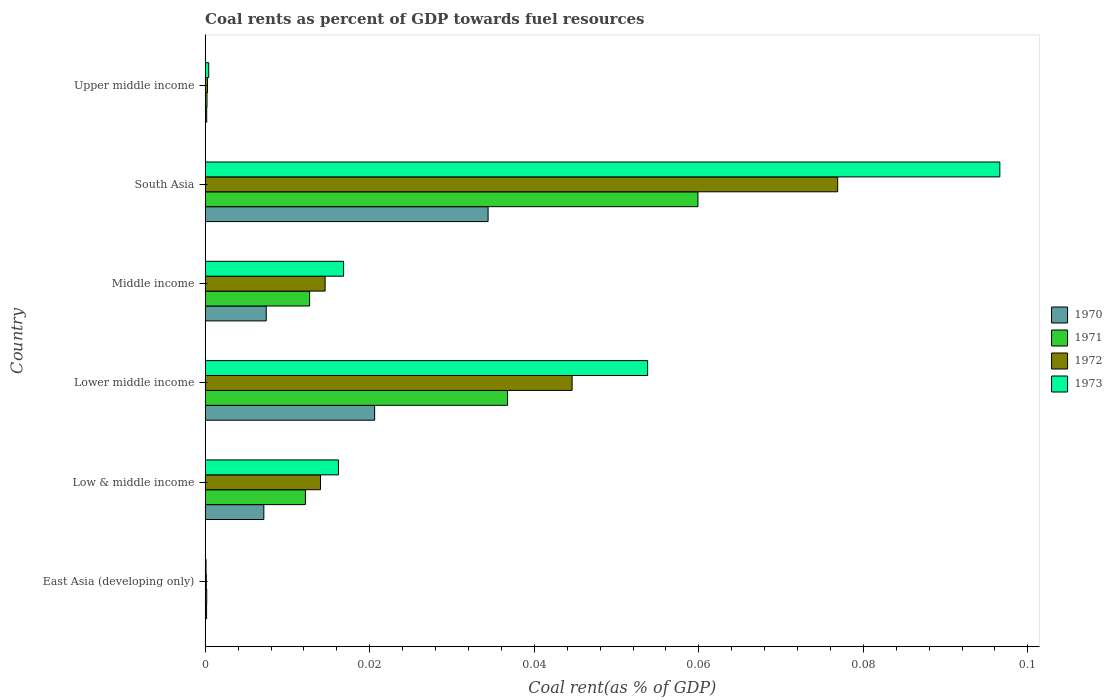How many different coloured bars are there?
Offer a very short reply. 4. How many groups of bars are there?
Your answer should be very brief. 6. Are the number of bars per tick equal to the number of legend labels?
Provide a short and direct response. Yes. Are the number of bars on each tick of the Y-axis equal?
Provide a short and direct response. Yes. How many bars are there on the 5th tick from the top?
Your response must be concise. 4. How many bars are there on the 3rd tick from the bottom?
Offer a terse response. 4. In how many cases, is the number of bars for a given country not equal to the number of legend labels?
Keep it short and to the point. 0. What is the coal rent in 1970 in East Asia (developing only)?
Provide a short and direct response. 0. Across all countries, what is the maximum coal rent in 1971?
Your response must be concise. 0.06. Across all countries, what is the minimum coal rent in 1973?
Your answer should be compact. 0. In which country was the coal rent in 1972 maximum?
Offer a very short reply. South Asia. In which country was the coal rent in 1971 minimum?
Your answer should be very brief. East Asia (developing only). What is the total coal rent in 1973 in the graph?
Your answer should be compact. 0.18. What is the difference between the coal rent in 1970 in Low & middle income and that in South Asia?
Your response must be concise. -0.03. What is the difference between the coal rent in 1973 in East Asia (developing only) and the coal rent in 1972 in Upper middle income?
Offer a terse response. -0. What is the average coal rent in 1971 per country?
Ensure brevity in your answer.  0.02. What is the difference between the coal rent in 1970 and coal rent in 1972 in South Asia?
Make the answer very short. -0.04. In how many countries, is the coal rent in 1970 greater than 0.068 %?
Your answer should be compact. 0. What is the ratio of the coal rent in 1971 in East Asia (developing only) to that in Middle income?
Ensure brevity in your answer.  0.01. Is the coal rent in 1970 in Lower middle income less than that in Middle income?
Provide a succinct answer. No. Is the difference between the coal rent in 1970 in Lower middle income and Middle income greater than the difference between the coal rent in 1972 in Lower middle income and Middle income?
Your answer should be very brief. No. What is the difference between the highest and the second highest coal rent in 1970?
Give a very brief answer. 0.01. What is the difference between the highest and the lowest coal rent in 1972?
Provide a succinct answer. 0.08. What does the 2nd bar from the bottom in East Asia (developing only) represents?
Offer a very short reply. 1971. Is it the case that in every country, the sum of the coal rent in 1972 and coal rent in 1970 is greater than the coal rent in 1973?
Keep it short and to the point. Yes. How many countries are there in the graph?
Provide a short and direct response. 6. What is the difference between two consecutive major ticks on the X-axis?
Your answer should be very brief. 0.02. Does the graph contain any zero values?
Make the answer very short. No. Does the graph contain grids?
Provide a short and direct response. No. How many legend labels are there?
Offer a terse response. 4. What is the title of the graph?
Your response must be concise. Coal rents as percent of GDP towards fuel resources. Does "1992" appear as one of the legend labels in the graph?
Offer a very short reply. No. What is the label or title of the X-axis?
Provide a succinct answer. Coal rent(as % of GDP). What is the Coal rent(as % of GDP) of 1970 in East Asia (developing only)?
Your answer should be very brief. 0. What is the Coal rent(as % of GDP) of 1971 in East Asia (developing only)?
Provide a succinct answer. 0. What is the Coal rent(as % of GDP) of 1972 in East Asia (developing only)?
Offer a very short reply. 0. What is the Coal rent(as % of GDP) in 1973 in East Asia (developing only)?
Provide a succinct answer. 0. What is the Coal rent(as % of GDP) in 1970 in Low & middle income?
Your answer should be compact. 0.01. What is the Coal rent(as % of GDP) of 1971 in Low & middle income?
Your answer should be compact. 0.01. What is the Coal rent(as % of GDP) of 1972 in Low & middle income?
Give a very brief answer. 0.01. What is the Coal rent(as % of GDP) in 1973 in Low & middle income?
Provide a short and direct response. 0.02. What is the Coal rent(as % of GDP) in 1970 in Lower middle income?
Offer a very short reply. 0.02. What is the Coal rent(as % of GDP) in 1971 in Lower middle income?
Keep it short and to the point. 0.04. What is the Coal rent(as % of GDP) in 1972 in Lower middle income?
Your answer should be very brief. 0.04. What is the Coal rent(as % of GDP) in 1973 in Lower middle income?
Give a very brief answer. 0.05. What is the Coal rent(as % of GDP) in 1970 in Middle income?
Provide a short and direct response. 0.01. What is the Coal rent(as % of GDP) in 1971 in Middle income?
Offer a terse response. 0.01. What is the Coal rent(as % of GDP) of 1972 in Middle income?
Offer a very short reply. 0.01. What is the Coal rent(as % of GDP) in 1973 in Middle income?
Offer a terse response. 0.02. What is the Coal rent(as % of GDP) of 1970 in South Asia?
Your answer should be very brief. 0.03. What is the Coal rent(as % of GDP) in 1971 in South Asia?
Provide a short and direct response. 0.06. What is the Coal rent(as % of GDP) in 1972 in South Asia?
Make the answer very short. 0.08. What is the Coal rent(as % of GDP) of 1973 in South Asia?
Offer a very short reply. 0.1. What is the Coal rent(as % of GDP) in 1970 in Upper middle income?
Ensure brevity in your answer.  0. What is the Coal rent(as % of GDP) in 1971 in Upper middle income?
Your response must be concise. 0. What is the Coal rent(as % of GDP) of 1972 in Upper middle income?
Provide a succinct answer. 0. What is the Coal rent(as % of GDP) in 1973 in Upper middle income?
Give a very brief answer. 0. Across all countries, what is the maximum Coal rent(as % of GDP) in 1970?
Keep it short and to the point. 0.03. Across all countries, what is the maximum Coal rent(as % of GDP) of 1971?
Your response must be concise. 0.06. Across all countries, what is the maximum Coal rent(as % of GDP) of 1972?
Offer a very short reply. 0.08. Across all countries, what is the maximum Coal rent(as % of GDP) of 1973?
Your answer should be very brief. 0.1. Across all countries, what is the minimum Coal rent(as % of GDP) in 1970?
Keep it short and to the point. 0. Across all countries, what is the minimum Coal rent(as % of GDP) of 1971?
Provide a short and direct response. 0. Across all countries, what is the minimum Coal rent(as % of GDP) in 1972?
Offer a terse response. 0. Across all countries, what is the minimum Coal rent(as % of GDP) of 1973?
Your answer should be very brief. 0. What is the total Coal rent(as % of GDP) in 1970 in the graph?
Offer a very short reply. 0.07. What is the total Coal rent(as % of GDP) of 1971 in the graph?
Your response must be concise. 0.12. What is the total Coal rent(as % of GDP) in 1972 in the graph?
Ensure brevity in your answer.  0.15. What is the total Coal rent(as % of GDP) of 1973 in the graph?
Keep it short and to the point. 0.18. What is the difference between the Coal rent(as % of GDP) in 1970 in East Asia (developing only) and that in Low & middle income?
Provide a short and direct response. -0.01. What is the difference between the Coal rent(as % of GDP) of 1971 in East Asia (developing only) and that in Low & middle income?
Your answer should be compact. -0.01. What is the difference between the Coal rent(as % of GDP) in 1972 in East Asia (developing only) and that in Low & middle income?
Make the answer very short. -0.01. What is the difference between the Coal rent(as % of GDP) in 1973 in East Asia (developing only) and that in Low & middle income?
Offer a terse response. -0.02. What is the difference between the Coal rent(as % of GDP) of 1970 in East Asia (developing only) and that in Lower middle income?
Offer a very short reply. -0.02. What is the difference between the Coal rent(as % of GDP) of 1971 in East Asia (developing only) and that in Lower middle income?
Your answer should be compact. -0.04. What is the difference between the Coal rent(as % of GDP) in 1972 in East Asia (developing only) and that in Lower middle income?
Keep it short and to the point. -0.04. What is the difference between the Coal rent(as % of GDP) of 1973 in East Asia (developing only) and that in Lower middle income?
Your response must be concise. -0.05. What is the difference between the Coal rent(as % of GDP) of 1970 in East Asia (developing only) and that in Middle income?
Your answer should be very brief. -0.01. What is the difference between the Coal rent(as % of GDP) of 1971 in East Asia (developing only) and that in Middle income?
Your response must be concise. -0.01. What is the difference between the Coal rent(as % of GDP) of 1972 in East Asia (developing only) and that in Middle income?
Offer a very short reply. -0.01. What is the difference between the Coal rent(as % of GDP) in 1973 in East Asia (developing only) and that in Middle income?
Make the answer very short. -0.02. What is the difference between the Coal rent(as % of GDP) in 1970 in East Asia (developing only) and that in South Asia?
Keep it short and to the point. -0.03. What is the difference between the Coal rent(as % of GDP) in 1971 in East Asia (developing only) and that in South Asia?
Give a very brief answer. -0.06. What is the difference between the Coal rent(as % of GDP) of 1972 in East Asia (developing only) and that in South Asia?
Make the answer very short. -0.08. What is the difference between the Coal rent(as % of GDP) in 1973 in East Asia (developing only) and that in South Asia?
Your answer should be compact. -0.1. What is the difference between the Coal rent(as % of GDP) of 1970 in East Asia (developing only) and that in Upper middle income?
Offer a very short reply. -0. What is the difference between the Coal rent(as % of GDP) in 1972 in East Asia (developing only) and that in Upper middle income?
Offer a terse response. -0. What is the difference between the Coal rent(as % of GDP) of 1973 in East Asia (developing only) and that in Upper middle income?
Ensure brevity in your answer.  -0. What is the difference between the Coal rent(as % of GDP) of 1970 in Low & middle income and that in Lower middle income?
Your answer should be compact. -0.01. What is the difference between the Coal rent(as % of GDP) in 1971 in Low & middle income and that in Lower middle income?
Offer a very short reply. -0.02. What is the difference between the Coal rent(as % of GDP) of 1972 in Low & middle income and that in Lower middle income?
Your response must be concise. -0.03. What is the difference between the Coal rent(as % of GDP) of 1973 in Low & middle income and that in Lower middle income?
Keep it short and to the point. -0.04. What is the difference between the Coal rent(as % of GDP) in 1970 in Low & middle income and that in Middle income?
Make the answer very short. -0. What is the difference between the Coal rent(as % of GDP) in 1971 in Low & middle income and that in Middle income?
Your response must be concise. -0. What is the difference between the Coal rent(as % of GDP) of 1972 in Low & middle income and that in Middle income?
Ensure brevity in your answer.  -0. What is the difference between the Coal rent(as % of GDP) of 1973 in Low & middle income and that in Middle income?
Provide a succinct answer. -0. What is the difference between the Coal rent(as % of GDP) in 1970 in Low & middle income and that in South Asia?
Your answer should be very brief. -0.03. What is the difference between the Coal rent(as % of GDP) in 1971 in Low & middle income and that in South Asia?
Your response must be concise. -0.05. What is the difference between the Coal rent(as % of GDP) of 1972 in Low & middle income and that in South Asia?
Make the answer very short. -0.06. What is the difference between the Coal rent(as % of GDP) of 1973 in Low & middle income and that in South Asia?
Ensure brevity in your answer.  -0.08. What is the difference between the Coal rent(as % of GDP) in 1970 in Low & middle income and that in Upper middle income?
Make the answer very short. 0.01. What is the difference between the Coal rent(as % of GDP) of 1971 in Low & middle income and that in Upper middle income?
Ensure brevity in your answer.  0.01. What is the difference between the Coal rent(as % of GDP) of 1972 in Low & middle income and that in Upper middle income?
Ensure brevity in your answer.  0.01. What is the difference between the Coal rent(as % of GDP) in 1973 in Low & middle income and that in Upper middle income?
Offer a terse response. 0.02. What is the difference between the Coal rent(as % of GDP) of 1970 in Lower middle income and that in Middle income?
Make the answer very short. 0.01. What is the difference between the Coal rent(as % of GDP) in 1971 in Lower middle income and that in Middle income?
Your response must be concise. 0.02. What is the difference between the Coal rent(as % of GDP) in 1972 in Lower middle income and that in Middle income?
Your answer should be very brief. 0.03. What is the difference between the Coal rent(as % of GDP) of 1973 in Lower middle income and that in Middle income?
Offer a terse response. 0.04. What is the difference between the Coal rent(as % of GDP) of 1970 in Lower middle income and that in South Asia?
Provide a short and direct response. -0.01. What is the difference between the Coal rent(as % of GDP) of 1971 in Lower middle income and that in South Asia?
Your answer should be very brief. -0.02. What is the difference between the Coal rent(as % of GDP) in 1972 in Lower middle income and that in South Asia?
Your answer should be very brief. -0.03. What is the difference between the Coal rent(as % of GDP) of 1973 in Lower middle income and that in South Asia?
Give a very brief answer. -0.04. What is the difference between the Coal rent(as % of GDP) in 1970 in Lower middle income and that in Upper middle income?
Your answer should be compact. 0.02. What is the difference between the Coal rent(as % of GDP) in 1971 in Lower middle income and that in Upper middle income?
Your response must be concise. 0.04. What is the difference between the Coal rent(as % of GDP) of 1972 in Lower middle income and that in Upper middle income?
Ensure brevity in your answer.  0.04. What is the difference between the Coal rent(as % of GDP) of 1973 in Lower middle income and that in Upper middle income?
Keep it short and to the point. 0.05. What is the difference between the Coal rent(as % of GDP) of 1970 in Middle income and that in South Asia?
Your response must be concise. -0.03. What is the difference between the Coal rent(as % of GDP) in 1971 in Middle income and that in South Asia?
Your response must be concise. -0.05. What is the difference between the Coal rent(as % of GDP) of 1972 in Middle income and that in South Asia?
Give a very brief answer. -0.06. What is the difference between the Coal rent(as % of GDP) in 1973 in Middle income and that in South Asia?
Make the answer very short. -0.08. What is the difference between the Coal rent(as % of GDP) in 1970 in Middle income and that in Upper middle income?
Offer a terse response. 0.01. What is the difference between the Coal rent(as % of GDP) of 1971 in Middle income and that in Upper middle income?
Offer a terse response. 0.01. What is the difference between the Coal rent(as % of GDP) of 1972 in Middle income and that in Upper middle income?
Your answer should be compact. 0.01. What is the difference between the Coal rent(as % of GDP) in 1973 in Middle income and that in Upper middle income?
Provide a succinct answer. 0.02. What is the difference between the Coal rent(as % of GDP) in 1970 in South Asia and that in Upper middle income?
Ensure brevity in your answer.  0.03. What is the difference between the Coal rent(as % of GDP) of 1971 in South Asia and that in Upper middle income?
Offer a terse response. 0.06. What is the difference between the Coal rent(as % of GDP) in 1972 in South Asia and that in Upper middle income?
Provide a short and direct response. 0.08. What is the difference between the Coal rent(as % of GDP) of 1973 in South Asia and that in Upper middle income?
Give a very brief answer. 0.1. What is the difference between the Coal rent(as % of GDP) of 1970 in East Asia (developing only) and the Coal rent(as % of GDP) of 1971 in Low & middle income?
Provide a succinct answer. -0.01. What is the difference between the Coal rent(as % of GDP) in 1970 in East Asia (developing only) and the Coal rent(as % of GDP) in 1972 in Low & middle income?
Make the answer very short. -0.01. What is the difference between the Coal rent(as % of GDP) in 1970 in East Asia (developing only) and the Coal rent(as % of GDP) in 1973 in Low & middle income?
Give a very brief answer. -0.02. What is the difference between the Coal rent(as % of GDP) of 1971 in East Asia (developing only) and the Coal rent(as % of GDP) of 1972 in Low & middle income?
Your answer should be compact. -0.01. What is the difference between the Coal rent(as % of GDP) in 1971 in East Asia (developing only) and the Coal rent(as % of GDP) in 1973 in Low & middle income?
Your answer should be very brief. -0.02. What is the difference between the Coal rent(as % of GDP) of 1972 in East Asia (developing only) and the Coal rent(as % of GDP) of 1973 in Low & middle income?
Offer a very short reply. -0.02. What is the difference between the Coal rent(as % of GDP) in 1970 in East Asia (developing only) and the Coal rent(as % of GDP) in 1971 in Lower middle income?
Your response must be concise. -0.04. What is the difference between the Coal rent(as % of GDP) of 1970 in East Asia (developing only) and the Coal rent(as % of GDP) of 1972 in Lower middle income?
Give a very brief answer. -0.04. What is the difference between the Coal rent(as % of GDP) of 1970 in East Asia (developing only) and the Coal rent(as % of GDP) of 1973 in Lower middle income?
Offer a terse response. -0.05. What is the difference between the Coal rent(as % of GDP) in 1971 in East Asia (developing only) and the Coal rent(as % of GDP) in 1972 in Lower middle income?
Offer a terse response. -0.04. What is the difference between the Coal rent(as % of GDP) in 1971 in East Asia (developing only) and the Coal rent(as % of GDP) in 1973 in Lower middle income?
Your answer should be very brief. -0.05. What is the difference between the Coal rent(as % of GDP) in 1972 in East Asia (developing only) and the Coal rent(as % of GDP) in 1973 in Lower middle income?
Provide a short and direct response. -0.05. What is the difference between the Coal rent(as % of GDP) of 1970 in East Asia (developing only) and the Coal rent(as % of GDP) of 1971 in Middle income?
Offer a very short reply. -0.01. What is the difference between the Coal rent(as % of GDP) of 1970 in East Asia (developing only) and the Coal rent(as % of GDP) of 1972 in Middle income?
Your response must be concise. -0.01. What is the difference between the Coal rent(as % of GDP) of 1970 in East Asia (developing only) and the Coal rent(as % of GDP) of 1973 in Middle income?
Offer a terse response. -0.02. What is the difference between the Coal rent(as % of GDP) in 1971 in East Asia (developing only) and the Coal rent(as % of GDP) in 1972 in Middle income?
Your answer should be compact. -0.01. What is the difference between the Coal rent(as % of GDP) in 1971 in East Asia (developing only) and the Coal rent(as % of GDP) in 1973 in Middle income?
Your answer should be compact. -0.02. What is the difference between the Coal rent(as % of GDP) in 1972 in East Asia (developing only) and the Coal rent(as % of GDP) in 1973 in Middle income?
Your answer should be very brief. -0.02. What is the difference between the Coal rent(as % of GDP) in 1970 in East Asia (developing only) and the Coal rent(as % of GDP) in 1971 in South Asia?
Offer a terse response. -0.06. What is the difference between the Coal rent(as % of GDP) in 1970 in East Asia (developing only) and the Coal rent(as % of GDP) in 1972 in South Asia?
Ensure brevity in your answer.  -0.08. What is the difference between the Coal rent(as % of GDP) in 1970 in East Asia (developing only) and the Coal rent(as % of GDP) in 1973 in South Asia?
Make the answer very short. -0.1. What is the difference between the Coal rent(as % of GDP) of 1971 in East Asia (developing only) and the Coal rent(as % of GDP) of 1972 in South Asia?
Offer a terse response. -0.08. What is the difference between the Coal rent(as % of GDP) in 1971 in East Asia (developing only) and the Coal rent(as % of GDP) in 1973 in South Asia?
Keep it short and to the point. -0.1. What is the difference between the Coal rent(as % of GDP) in 1972 in East Asia (developing only) and the Coal rent(as % of GDP) in 1973 in South Asia?
Give a very brief answer. -0.1. What is the difference between the Coal rent(as % of GDP) of 1970 in East Asia (developing only) and the Coal rent(as % of GDP) of 1971 in Upper middle income?
Provide a short and direct response. -0. What is the difference between the Coal rent(as % of GDP) in 1970 in East Asia (developing only) and the Coal rent(as % of GDP) in 1972 in Upper middle income?
Give a very brief answer. -0. What is the difference between the Coal rent(as % of GDP) in 1970 in East Asia (developing only) and the Coal rent(as % of GDP) in 1973 in Upper middle income?
Offer a very short reply. -0. What is the difference between the Coal rent(as % of GDP) in 1971 in East Asia (developing only) and the Coal rent(as % of GDP) in 1972 in Upper middle income?
Your answer should be very brief. -0. What is the difference between the Coal rent(as % of GDP) in 1971 in East Asia (developing only) and the Coal rent(as % of GDP) in 1973 in Upper middle income?
Keep it short and to the point. -0. What is the difference between the Coal rent(as % of GDP) in 1972 in East Asia (developing only) and the Coal rent(as % of GDP) in 1973 in Upper middle income?
Your answer should be very brief. -0. What is the difference between the Coal rent(as % of GDP) of 1970 in Low & middle income and the Coal rent(as % of GDP) of 1971 in Lower middle income?
Provide a succinct answer. -0.03. What is the difference between the Coal rent(as % of GDP) in 1970 in Low & middle income and the Coal rent(as % of GDP) in 1972 in Lower middle income?
Give a very brief answer. -0.04. What is the difference between the Coal rent(as % of GDP) of 1970 in Low & middle income and the Coal rent(as % of GDP) of 1973 in Lower middle income?
Offer a terse response. -0.05. What is the difference between the Coal rent(as % of GDP) of 1971 in Low & middle income and the Coal rent(as % of GDP) of 1972 in Lower middle income?
Give a very brief answer. -0.03. What is the difference between the Coal rent(as % of GDP) in 1971 in Low & middle income and the Coal rent(as % of GDP) in 1973 in Lower middle income?
Your answer should be compact. -0.04. What is the difference between the Coal rent(as % of GDP) of 1972 in Low & middle income and the Coal rent(as % of GDP) of 1973 in Lower middle income?
Give a very brief answer. -0.04. What is the difference between the Coal rent(as % of GDP) in 1970 in Low & middle income and the Coal rent(as % of GDP) in 1971 in Middle income?
Offer a terse response. -0.01. What is the difference between the Coal rent(as % of GDP) of 1970 in Low & middle income and the Coal rent(as % of GDP) of 1972 in Middle income?
Your answer should be very brief. -0.01. What is the difference between the Coal rent(as % of GDP) of 1970 in Low & middle income and the Coal rent(as % of GDP) of 1973 in Middle income?
Provide a succinct answer. -0.01. What is the difference between the Coal rent(as % of GDP) in 1971 in Low & middle income and the Coal rent(as % of GDP) in 1972 in Middle income?
Your response must be concise. -0. What is the difference between the Coal rent(as % of GDP) of 1971 in Low & middle income and the Coal rent(as % of GDP) of 1973 in Middle income?
Give a very brief answer. -0. What is the difference between the Coal rent(as % of GDP) in 1972 in Low & middle income and the Coal rent(as % of GDP) in 1973 in Middle income?
Give a very brief answer. -0. What is the difference between the Coal rent(as % of GDP) in 1970 in Low & middle income and the Coal rent(as % of GDP) in 1971 in South Asia?
Ensure brevity in your answer.  -0.05. What is the difference between the Coal rent(as % of GDP) of 1970 in Low & middle income and the Coal rent(as % of GDP) of 1972 in South Asia?
Offer a very short reply. -0.07. What is the difference between the Coal rent(as % of GDP) in 1970 in Low & middle income and the Coal rent(as % of GDP) in 1973 in South Asia?
Offer a very short reply. -0.09. What is the difference between the Coal rent(as % of GDP) in 1971 in Low & middle income and the Coal rent(as % of GDP) in 1972 in South Asia?
Your answer should be very brief. -0.06. What is the difference between the Coal rent(as % of GDP) in 1971 in Low & middle income and the Coal rent(as % of GDP) in 1973 in South Asia?
Your answer should be very brief. -0.08. What is the difference between the Coal rent(as % of GDP) of 1972 in Low & middle income and the Coal rent(as % of GDP) of 1973 in South Asia?
Your answer should be compact. -0.08. What is the difference between the Coal rent(as % of GDP) of 1970 in Low & middle income and the Coal rent(as % of GDP) of 1971 in Upper middle income?
Offer a terse response. 0.01. What is the difference between the Coal rent(as % of GDP) of 1970 in Low & middle income and the Coal rent(as % of GDP) of 1972 in Upper middle income?
Offer a very short reply. 0.01. What is the difference between the Coal rent(as % of GDP) in 1970 in Low & middle income and the Coal rent(as % of GDP) in 1973 in Upper middle income?
Give a very brief answer. 0.01. What is the difference between the Coal rent(as % of GDP) in 1971 in Low & middle income and the Coal rent(as % of GDP) in 1972 in Upper middle income?
Provide a short and direct response. 0.01. What is the difference between the Coal rent(as % of GDP) in 1971 in Low & middle income and the Coal rent(as % of GDP) in 1973 in Upper middle income?
Your response must be concise. 0.01. What is the difference between the Coal rent(as % of GDP) of 1972 in Low & middle income and the Coal rent(as % of GDP) of 1973 in Upper middle income?
Offer a very short reply. 0.01. What is the difference between the Coal rent(as % of GDP) of 1970 in Lower middle income and the Coal rent(as % of GDP) of 1971 in Middle income?
Ensure brevity in your answer.  0.01. What is the difference between the Coal rent(as % of GDP) of 1970 in Lower middle income and the Coal rent(as % of GDP) of 1972 in Middle income?
Make the answer very short. 0.01. What is the difference between the Coal rent(as % of GDP) of 1970 in Lower middle income and the Coal rent(as % of GDP) of 1973 in Middle income?
Keep it short and to the point. 0. What is the difference between the Coal rent(as % of GDP) of 1971 in Lower middle income and the Coal rent(as % of GDP) of 1972 in Middle income?
Your response must be concise. 0.02. What is the difference between the Coal rent(as % of GDP) in 1971 in Lower middle income and the Coal rent(as % of GDP) in 1973 in Middle income?
Your response must be concise. 0.02. What is the difference between the Coal rent(as % of GDP) in 1972 in Lower middle income and the Coal rent(as % of GDP) in 1973 in Middle income?
Your answer should be compact. 0.03. What is the difference between the Coal rent(as % of GDP) of 1970 in Lower middle income and the Coal rent(as % of GDP) of 1971 in South Asia?
Your response must be concise. -0.04. What is the difference between the Coal rent(as % of GDP) in 1970 in Lower middle income and the Coal rent(as % of GDP) in 1972 in South Asia?
Your answer should be very brief. -0.06. What is the difference between the Coal rent(as % of GDP) of 1970 in Lower middle income and the Coal rent(as % of GDP) of 1973 in South Asia?
Offer a very short reply. -0.08. What is the difference between the Coal rent(as % of GDP) of 1971 in Lower middle income and the Coal rent(as % of GDP) of 1972 in South Asia?
Your answer should be compact. -0.04. What is the difference between the Coal rent(as % of GDP) of 1971 in Lower middle income and the Coal rent(as % of GDP) of 1973 in South Asia?
Your answer should be compact. -0.06. What is the difference between the Coal rent(as % of GDP) in 1972 in Lower middle income and the Coal rent(as % of GDP) in 1973 in South Asia?
Make the answer very short. -0.05. What is the difference between the Coal rent(as % of GDP) in 1970 in Lower middle income and the Coal rent(as % of GDP) in 1971 in Upper middle income?
Your answer should be very brief. 0.02. What is the difference between the Coal rent(as % of GDP) of 1970 in Lower middle income and the Coal rent(as % of GDP) of 1972 in Upper middle income?
Offer a very short reply. 0.02. What is the difference between the Coal rent(as % of GDP) in 1970 in Lower middle income and the Coal rent(as % of GDP) in 1973 in Upper middle income?
Your response must be concise. 0.02. What is the difference between the Coal rent(as % of GDP) of 1971 in Lower middle income and the Coal rent(as % of GDP) of 1972 in Upper middle income?
Your answer should be very brief. 0.04. What is the difference between the Coal rent(as % of GDP) of 1971 in Lower middle income and the Coal rent(as % of GDP) of 1973 in Upper middle income?
Ensure brevity in your answer.  0.04. What is the difference between the Coal rent(as % of GDP) in 1972 in Lower middle income and the Coal rent(as % of GDP) in 1973 in Upper middle income?
Your answer should be very brief. 0.04. What is the difference between the Coal rent(as % of GDP) in 1970 in Middle income and the Coal rent(as % of GDP) in 1971 in South Asia?
Your answer should be compact. -0.05. What is the difference between the Coal rent(as % of GDP) of 1970 in Middle income and the Coal rent(as % of GDP) of 1972 in South Asia?
Give a very brief answer. -0.07. What is the difference between the Coal rent(as % of GDP) of 1970 in Middle income and the Coal rent(as % of GDP) of 1973 in South Asia?
Give a very brief answer. -0.09. What is the difference between the Coal rent(as % of GDP) in 1971 in Middle income and the Coal rent(as % of GDP) in 1972 in South Asia?
Provide a succinct answer. -0.06. What is the difference between the Coal rent(as % of GDP) of 1971 in Middle income and the Coal rent(as % of GDP) of 1973 in South Asia?
Give a very brief answer. -0.08. What is the difference between the Coal rent(as % of GDP) of 1972 in Middle income and the Coal rent(as % of GDP) of 1973 in South Asia?
Your response must be concise. -0.08. What is the difference between the Coal rent(as % of GDP) in 1970 in Middle income and the Coal rent(as % of GDP) in 1971 in Upper middle income?
Your answer should be compact. 0.01. What is the difference between the Coal rent(as % of GDP) of 1970 in Middle income and the Coal rent(as % of GDP) of 1972 in Upper middle income?
Make the answer very short. 0.01. What is the difference between the Coal rent(as % of GDP) of 1970 in Middle income and the Coal rent(as % of GDP) of 1973 in Upper middle income?
Keep it short and to the point. 0.01. What is the difference between the Coal rent(as % of GDP) in 1971 in Middle income and the Coal rent(as % of GDP) in 1972 in Upper middle income?
Make the answer very short. 0.01. What is the difference between the Coal rent(as % of GDP) in 1971 in Middle income and the Coal rent(as % of GDP) in 1973 in Upper middle income?
Give a very brief answer. 0.01. What is the difference between the Coal rent(as % of GDP) of 1972 in Middle income and the Coal rent(as % of GDP) of 1973 in Upper middle income?
Provide a succinct answer. 0.01. What is the difference between the Coal rent(as % of GDP) in 1970 in South Asia and the Coal rent(as % of GDP) in 1971 in Upper middle income?
Your answer should be compact. 0.03. What is the difference between the Coal rent(as % of GDP) of 1970 in South Asia and the Coal rent(as % of GDP) of 1972 in Upper middle income?
Offer a terse response. 0.03. What is the difference between the Coal rent(as % of GDP) of 1970 in South Asia and the Coal rent(as % of GDP) of 1973 in Upper middle income?
Keep it short and to the point. 0.03. What is the difference between the Coal rent(as % of GDP) in 1971 in South Asia and the Coal rent(as % of GDP) in 1972 in Upper middle income?
Provide a short and direct response. 0.06. What is the difference between the Coal rent(as % of GDP) in 1971 in South Asia and the Coal rent(as % of GDP) in 1973 in Upper middle income?
Make the answer very short. 0.06. What is the difference between the Coal rent(as % of GDP) of 1972 in South Asia and the Coal rent(as % of GDP) of 1973 in Upper middle income?
Your response must be concise. 0.08. What is the average Coal rent(as % of GDP) in 1970 per country?
Offer a very short reply. 0.01. What is the average Coal rent(as % of GDP) of 1971 per country?
Keep it short and to the point. 0.02. What is the average Coal rent(as % of GDP) in 1972 per country?
Keep it short and to the point. 0.03. What is the average Coal rent(as % of GDP) of 1973 per country?
Your answer should be very brief. 0.03. What is the difference between the Coal rent(as % of GDP) in 1970 and Coal rent(as % of GDP) in 1973 in East Asia (developing only)?
Ensure brevity in your answer.  0. What is the difference between the Coal rent(as % of GDP) of 1970 and Coal rent(as % of GDP) of 1971 in Low & middle income?
Make the answer very short. -0.01. What is the difference between the Coal rent(as % of GDP) of 1970 and Coal rent(as % of GDP) of 1972 in Low & middle income?
Ensure brevity in your answer.  -0.01. What is the difference between the Coal rent(as % of GDP) in 1970 and Coal rent(as % of GDP) in 1973 in Low & middle income?
Make the answer very short. -0.01. What is the difference between the Coal rent(as % of GDP) of 1971 and Coal rent(as % of GDP) of 1972 in Low & middle income?
Your answer should be compact. -0. What is the difference between the Coal rent(as % of GDP) of 1971 and Coal rent(as % of GDP) of 1973 in Low & middle income?
Your response must be concise. -0. What is the difference between the Coal rent(as % of GDP) in 1972 and Coal rent(as % of GDP) in 1973 in Low & middle income?
Your answer should be compact. -0. What is the difference between the Coal rent(as % of GDP) of 1970 and Coal rent(as % of GDP) of 1971 in Lower middle income?
Ensure brevity in your answer.  -0.02. What is the difference between the Coal rent(as % of GDP) of 1970 and Coal rent(as % of GDP) of 1972 in Lower middle income?
Offer a terse response. -0.02. What is the difference between the Coal rent(as % of GDP) in 1970 and Coal rent(as % of GDP) in 1973 in Lower middle income?
Give a very brief answer. -0.03. What is the difference between the Coal rent(as % of GDP) in 1971 and Coal rent(as % of GDP) in 1972 in Lower middle income?
Your answer should be compact. -0.01. What is the difference between the Coal rent(as % of GDP) of 1971 and Coal rent(as % of GDP) of 1973 in Lower middle income?
Your response must be concise. -0.02. What is the difference between the Coal rent(as % of GDP) of 1972 and Coal rent(as % of GDP) of 1973 in Lower middle income?
Your answer should be compact. -0.01. What is the difference between the Coal rent(as % of GDP) in 1970 and Coal rent(as % of GDP) in 1971 in Middle income?
Offer a very short reply. -0.01. What is the difference between the Coal rent(as % of GDP) of 1970 and Coal rent(as % of GDP) of 1972 in Middle income?
Provide a short and direct response. -0.01. What is the difference between the Coal rent(as % of GDP) of 1970 and Coal rent(as % of GDP) of 1973 in Middle income?
Provide a short and direct response. -0.01. What is the difference between the Coal rent(as % of GDP) in 1971 and Coal rent(as % of GDP) in 1972 in Middle income?
Ensure brevity in your answer.  -0. What is the difference between the Coal rent(as % of GDP) in 1971 and Coal rent(as % of GDP) in 1973 in Middle income?
Ensure brevity in your answer.  -0. What is the difference between the Coal rent(as % of GDP) of 1972 and Coal rent(as % of GDP) of 1973 in Middle income?
Give a very brief answer. -0. What is the difference between the Coal rent(as % of GDP) in 1970 and Coal rent(as % of GDP) in 1971 in South Asia?
Provide a short and direct response. -0.03. What is the difference between the Coal rent(as % of GDP) in 1970 and Coal rent(as % of GDP) in 1972 in South Asia?
Ensure brevity in your answer.  -0.04. What is the difference between the Coal rent(as % of GDP) in 1970 and Coal rent(as % of GDP) in 1973 in South Asia?
Offer a very short reply. -0.06. What is the difference between the Coal rent(as % of GDP) of 1971 and Coal rent(as % of GDP) of 1972 in South Asia?
Make the answer very short. -0.02. What is the difference between the Coal rent(as % of GDP) of 1971 and Coal rent(as % of GDP) of 1973 in South Asia?
Keep it short and to the point. -0.04. What is the difference between the Coal rent(as % of GDP) in 1972 and Coal rent(as % of GDP) in 1973 in South Asia?
Your answer should be very brief. -0.02. What is the difference between the Coal rent(as % of GDP) of 1970 and Coal rent(as % of GDP) of 1972 in Upper middle income?
Your response must be concise. -0. What is the difference between the Coal rent(as % of GDP) in 1970 and Coal rent(as % of GDP) in 1973 in Upper middle income?
Your answer should be very brief. -0. What is the difference between the Coal rent(as % of GDP) in 1971 and Coal rent(as % of GDP) in 1972 in Upper middle income?
Ensure brevity in your answer.  -0. What is the difference between the Coal rent(as % of GDP) of 1971 and Coal rent(as % of GDP) of 1973 in Upper middle income?
Provide a short and direct response. -0. What is the difference between the Coal rent(as % of GDP) in 1972 and Coal rent(as % of GDP) in 1973 in Upper middle income?
Provide a short and direct response. -0. What is the ratio of the Coal rent(as % of GDP) in 1970 in East Asia (developing only) to that in Low & middle income?
Offer a terse response. 0.02. What is the ratio of the Coal rent(as % of GDP) of 1971 in East Asia (developing only) to that in Low & middle income?
Provide a short and direct response. 0.02. What is the ratio of the Coal rent(as % of GDP) of 1972 in East Asia (developing only) to that in Low & middle income?
Your response must be concise. 0.01. What is the ratio of the Coal rent(as % of GDP) of 1973 in East Asia (developing only) to that in Low & middle income?
Keep it short and to the point. 0.01. What is the ratio of the Coal rent(as % of GDP) in 1970 in East Asia (developing only) to that in Lower middle income?
Keep it short and to the point. 0.01. What is the ratio of the Coal rent(as % of GDP) of 1971 in East Asia (developing only) to that in Lower middle income?
Offer a terse response. 0.01. What is the ratio of the Coal rent(as % of GDP) in 1972 in East Asia (developing only) to that in Lower middle income?
Your answer should be compact. 0. What is the ratio of the Coal rent(as % of GDP) of 1973 in East Asia (developing only) to that in Lower middle income?
Provide a succinct answer. 0. What is the ratio of the Coal rent(as % of GDP) in 1970 in East Asia (developing only) to that in Middle income?
Ensure brevity in your answer.  0.02. What is the ratio of the Coal rent(as % of GDP) in 1971 in East Asia (developing only) to that in Middle income?
Your answer should be compact. 0.01. What is the ratio of the Coal rent(as % of GDP) in 1972 in East Asia (developing only) to that in Middle income?
Your answer should be compact. 0.01. What is the ratio of the Coal rent(as % of GDP) of 1973 in East Asia (developing only) to that in Middle income?
Your answer should be very brief. 0.01. What is the ratio of the Coal rent(as % of GDP) in 1970 in East Asia (developing only) to that in South Asia?
Your answer should be very brief. 0. What is the ratio of the Coal rent(as % of GDP) in 1971 in East Asia (developing only) to that in South Asia?
Give a very brief answer. 0. What is the ratio of the Coal rent(as % of GDP) of 1972 in East Asia (developing only) to that in South Asia?
Make the answer very short. 0. What is the ratio of the Coal rent(as % of GDP) of 1973 in East Asia (developing only) to that in South Asia?
Your response must be concise. 0. What is the ratio of the Coal rent(as % of GDP) of 1970 in East Asia (developing only) to that in Upper middle income?
Your answer should be very brief. 0.91. What is the ratio of the Coal rent(as % of GDP) in 1971 in East Asia (developing only) to that in Upper middle income?
Offer a terse response. 0.86. What is the ratio of the Coal rent(as % of GDP) of 1972 in East Asia (developing only) to that in Upper middle income?
Provide a succinct answer. 0.48. What is the ratio of the Coal rent(as % of GDP) of 1973 in East Asia (developing only) to that in Upper middle income?
Your answer should be very brief. 0.24. What is the ratio of the Coal rent(as % of GDP) of 1970 in Low & middle income to that in Lower middle income?
Make the answer very short. 0.35. What is the ratio of the Coal rent(as % of GDP) of 1971 in Low & middle income to that in Lower middle income?
Provide a short and direct response. 0.33. What is the ratio of the Coal rent(as % of GDP) of 1972 in Low & middle income to that in Lower middle income?
Offer a very short reply. 0.31. What is the ratio of the Coal rent(as % of GDP) of 1973 in Low & middle income to that in Lower middle income?
Provide a short and direct response. 0.3. What is the ratio of the Coal rent(as % of GDP) in 1970 in Low & middle income to that in Middle income?
Make the answer very short. 0.96. What is the ratio of the Coal rent(as % of GDP) in 1971 in Low & middle income to that in Middle income?
Provide a succinct answer. 0.96. What is the ratio of the Coal rent(as % of GDP) of 1972 in Low & middle income to that in Middle income?
Provide a short and direct response. 0.96. What is the ratio of the Coal rent(as % of GDP) in 1973 in Low & middle income to that in Middle income?
Provide a short and direct response. 0.96. What is the ratio of the Coal rent(as % of GDP) in 1970 in Low & middle income to that in South Asia?
Provide a short and direct response. 0.21. What is the ratio of the Coal rent(as % of GDP) of 1971 in Low & middle income to that in South Asia?
Your response must be concise. 0.2. What is the ratio of the Coal rent(as % of GDP) in 1972 in Low & middle income to that in South Asia?
Offer a terse response. 0.18. What is the ratio of the Coal rent(as % of GDP) of 1973 in Low & middle income to that in South Asia?
Offer a very short reply. 0.17. What is the ratio of the Coal rent(as % of GDP) in 1970 in Low & middle income to that in Upper middle income?
Your answer should be compact. 38.77. What is the ratio of the Coal rent(as % of GDP) in 1971 in Low & middle income to that in Upper middle income?
Offer a terse response. 55.66. What is the ratio of the Coal rent(as % of GDP) in 1972 in Low & middle income to that in Upper middle income?
Your answer should be very brief. 49.28. What is the ratio of the Coal rent(as % of GDP) in 1973 in Low & middle income to that in Upper middle income?
Offer a very short reply. 37.59. What is the ratio of the Coal rent(as % of GDP) in 1970 in Lower middle income to that in Middle income?
Ensure brevity in your answer.  2.78. What is the ratio of the Coal rent(as % of GDP) of 1971 in Lower middle income to that in Middle income?
Ensure brevity in your answer.  2.9. What is the ratio of the Coal rent(as % of GDP) of 1972 in Lower middle income to that in Middle income?
Your answer should be very brief. 3.06. What is the ratio of the Coal rent(as % of GDP) in 1973 in Lower middle income to that in Middle income?
Keep it short and to the point. 3.2. What is the ratio of the Coal rent(as % of GDP) of 1970 in Lower middle income to that in South Asia?
Keep it short and to the point. 0.6. What is the ratio of the Coal rent(as % of GDP) in 1971 in Lower middle income to that in South Asia?
Offer a very short reply. 0.61. What is the ratio of the Coal rent(as % of GDP) in 1972 in Lower middle income to that in South Asia?
Provide a succinct answer. 0.58. What is the ratio of the Coal rent(as % of GDP) of 1973 in Lower middle income to that in South Asia?
Provide a succinct answer. 0.56. What is the ratio of the Coal rent(as % of GDP) of 1970 in Lower middle income to that in Upper middle income?
Your response must be concise. 112.03. What is the ratio of the Coal rent(as % of GDP) in 1971 in Lower middle income to that in Upper middle income?
Offer a terse response. 167.98. What is the ratio of the Coal rent(as % of GDP) in 1972 in Lower middle income to that in Upper middle income?
Ensure brevity in your answer.  156.82. What is the ratio of the Coal rent(as % of GDP) of 1973 in Lower middle income to that in Upper middle income?
Your answer should be very brief. 124.82. What is the ratio of the Coal rent(as % of GDP) in 1970 in Middle income to that in South Asia?
Provide a short and direct response. 0.22. What is the ratio of the Coal rent(as % of GDP) in 1971 in Middle income to that in South Asia?
Keep it short and to the point. 0.21. What is the ratio of the Coal rent(as % of GDP) of 1972 in Middle income to that in South Asia?
Make the answer very short. 0.19. What is the ratio of the Coal rent(as % of GDP) of 1973 in Middle income to that in South Asia?
Your response must be concise. 0.17. What is the ratio of the Coal rent(as % of GDP) of 1970 in Middle income to that in Upper middle income?
Your response must be concise. 40.36. What is the ratio of the Coal rent(as % of GDP) of 1971 in Middle income to that in Upper middle income?
Your answer should be compact. 58.01. What is the ratio of the Coal rent(as % of GDP) in 1972 in Middle income to that in Upper middle income?
Your answer should be very brief. 51.25. What is the ratio of the Coal rent(as % of GDP) in 1973 in Middle income to that in Upper middle income?
Your answer should be very brief. 39.04. What is the ratio of the Coal rent(as % of GDP) in 1970 in South Asia to that in Upper middle income?
Provide a short and direct response. 187.05. What is the ratio of the Coal rent(as % of GDP) of 1971 in South Asia to that in Upper middle income?
Your answer should be very brief. 273.74. What is the ratio of the Coal rent(as % of GDP) of 1972 in South Asia to that in Upper middle income?
Your response must be concise. 270.32. What is the ratio of the Coal rent(as % of GDP) of 1973 in South Asia to that in Upper middle income?
Keep it short and to the point. 224.18. What is the difference between the highest and the second highest Coal rent(as % of GDP) in 1970?
Provide a succinct answer. 0.01. What is the difference between the highest and the second highest Coal rent(as % of GDP) in 1971?
Your response must be concise. 0.02. What is the difference between the highest and the second highest Coal rent(as % of GDP) in 1972?
Your response must be concise. 0.03. What is the difference between the highest and the second highest Coal rent(as % of GDP) in 1973?
Keep it short and to the point. 0.04. What is the difference between the highest and the lowest Coal rent(as % of GDP) of 1970?
Provide a succinct answer. 0.03. What is the difference between the highest and the lowest Coal rent(as % of GDP) of 1971?
Make the answer very short. 0.06. What is the difference between the highest and the lowest Coal rent(as % of GDP) in 1972?
Keep it short and to the point. 0.08. What is the difference between the highest and the lowest Coal rent(as % of GDP) of 1973?
Your answer should be very brief. 0.1. 